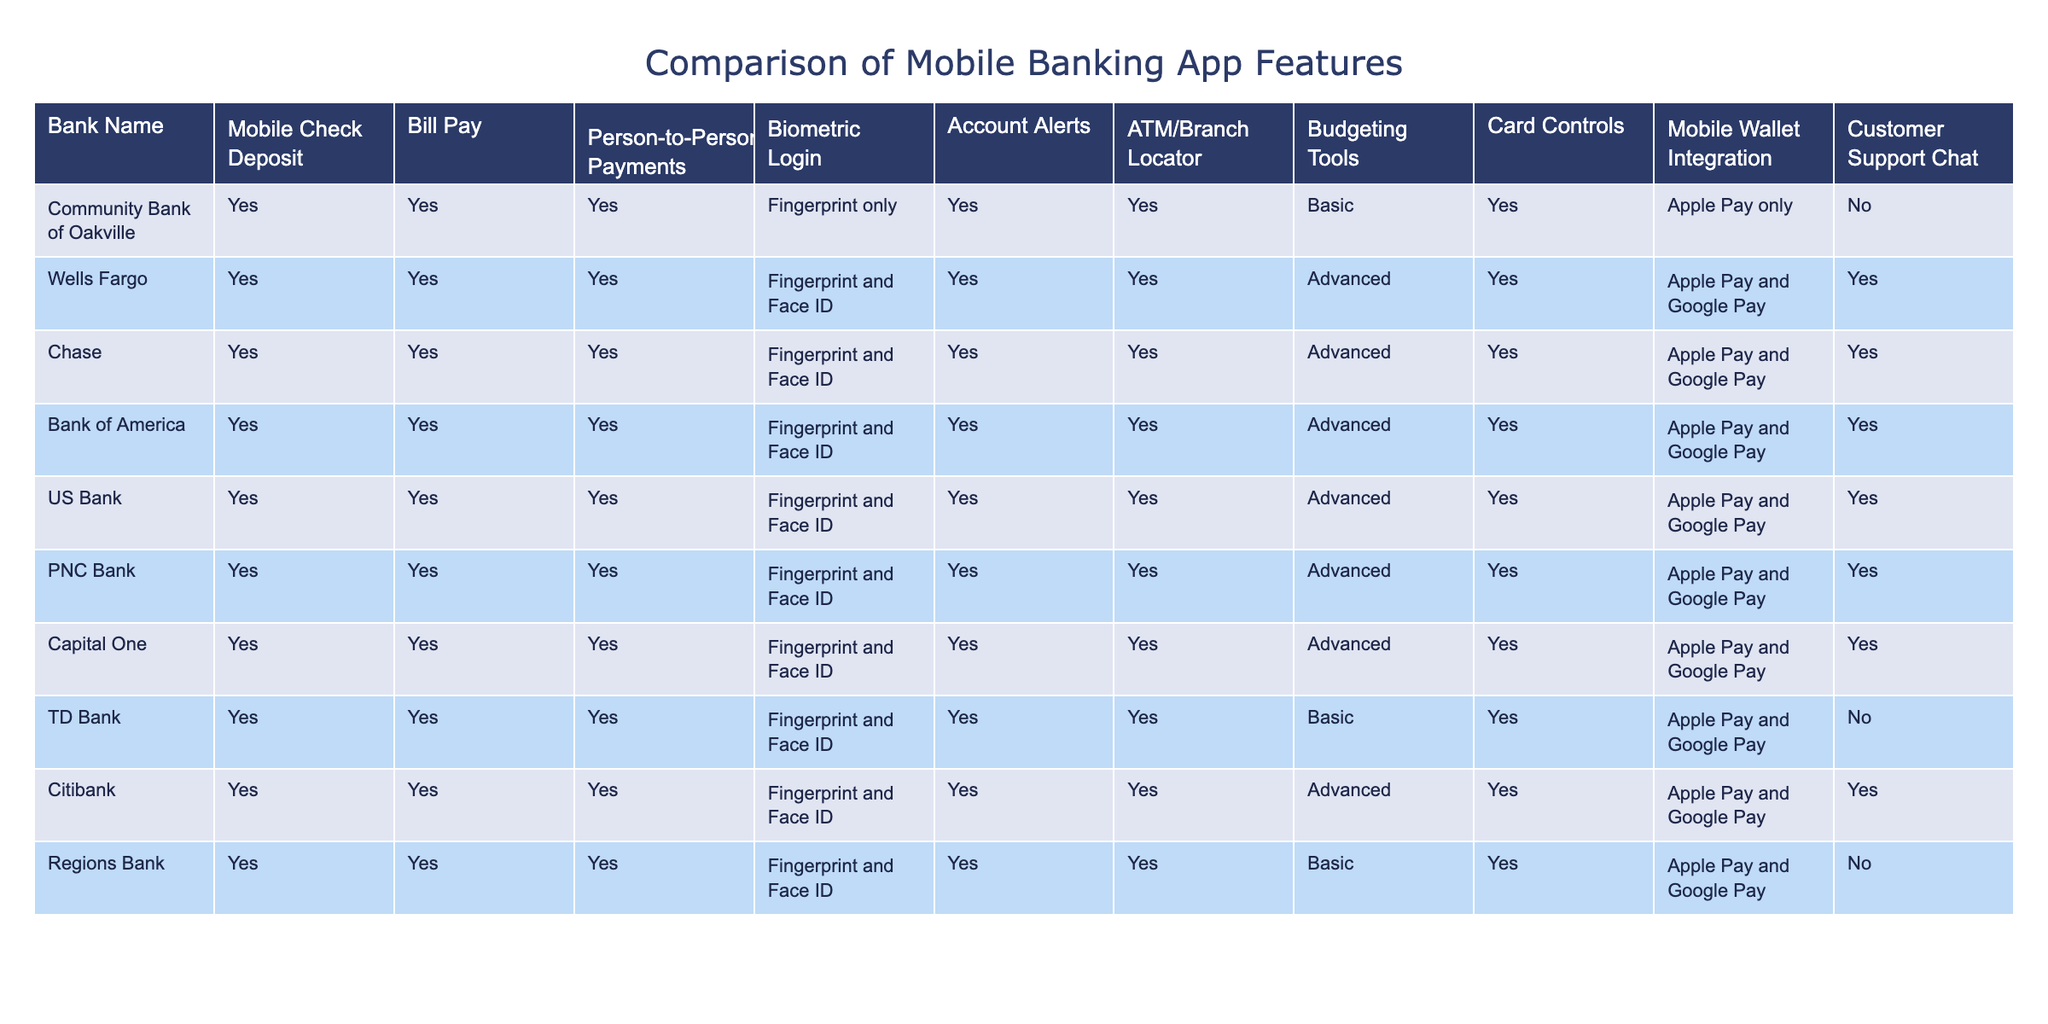What features does the Community Bank of Oakville lack compared to major competitors? The Community Bank of Oakville lacks advanced budgeting tools and does not support multiple mobile wallet integrations like Apple Pay and Google Pay, which several competitors do.
Answer: Advanced budgeting tools, multiple mobile wallet integrations Which banks offer biometric login options beyond fingerprint authentication? Wells Fargo, Chase, Bank of America, US Bank, PNC Bank, and Capital One provide both fingerprint and Face ID authentication, while Community Bank of Oakville offers fingerprint only.
Answer: Wells Fargo, Chase, Bank of America, US Bank, PNC Bank, Capital One How many banks offer customer support chat among the competitors? Looking at the table, only Wells Fargo, Chase, Bank of America, US Bank, PNC Bank, and Citibank provide customer support chat. Thus, there are 6 banks offering this feature.
Answer: 6 banks What is the difference in the number of banks offering basic versus advanced budgeting tools? Three banks, including Community Bank of Oakville, TD Bank, and Regions Bank, offer basic budgeting tools, whereas six banks offer advanced budgeting tools. Thus, the difference in the number of banks is 6 - 3 = 3.
Answer: 3 Is there any bank that does not support card controls, like the Community Bank of Oakville? Yes, the Community Bank of Oakville does not support customer support chat, but all other banks in the table provide card controls, confirming that Community Bank of Oakville is unique in this aspect.
Answer: Yes, Community Bank of Oakville Which banks have the most features in common with the Community Bank of Oakville? Community Bank of Oakville shares the same features as TD Bank when it comes to mobile check deposit, bill pay, person-to-person payments, biometric login, account alerts, ATM/branch locator, and card controls, making both banks very similar in offerings.
Answer: TD Bank 